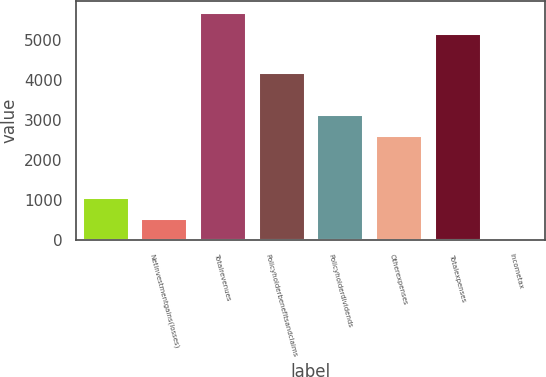<chart> <loc_0><loc_0><loc_500><loc_500><bar_chart><ecel><fcel>Netinvestmentgains(losses)<fcel>Totalrevenues<fcel>Policyholderbenefitsandclaims<fcel>Policyholderdividends<fcel>Otherexpenses<fcel>Totalexpenses<fcel>Incometax<nl><fcel>1066.4<fcel>543.7<fcel>5702.7<fcel>4202.6<fcel>3157.2<fcel>2634.5<fcel>5180<fcel>21<nl></chart> 